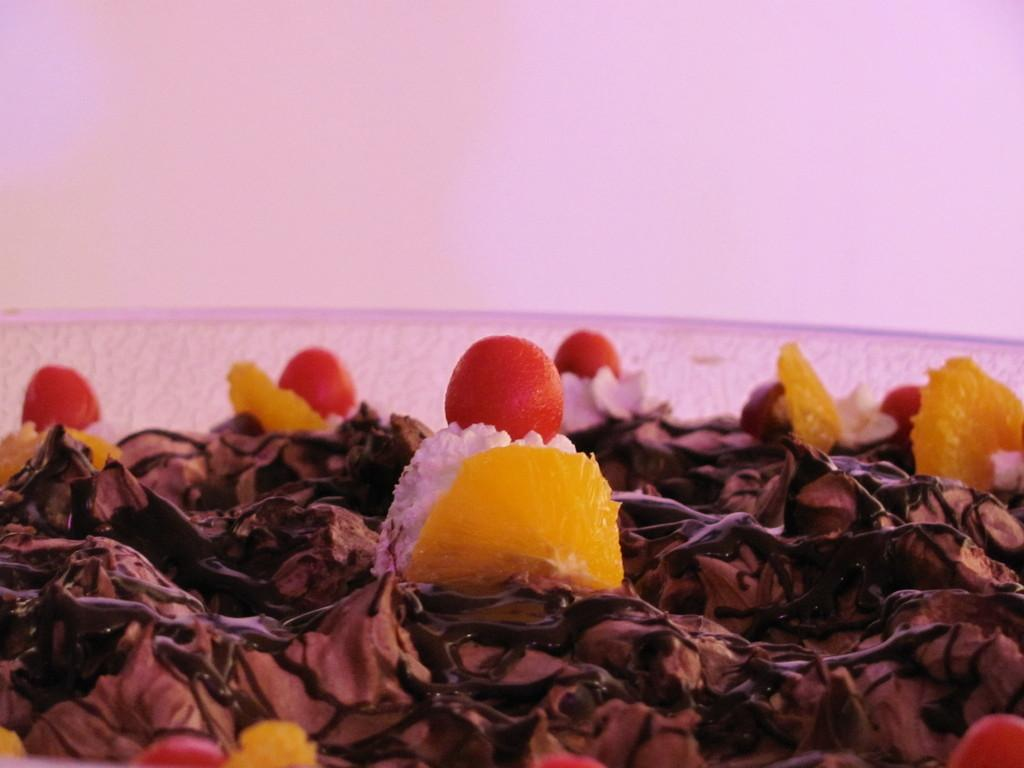What is the main subject of the image? The main subject of the image is a cake. What decorations are on the cake? There are red color cherries on the cake. What type of property is being sold in the image? There is no property being sold in the image; it features a cake with red color cherries. What is the cause of the cough in the image? There is no cough or any indication of a medical condition in the image; it features a cake with red color cherries. 